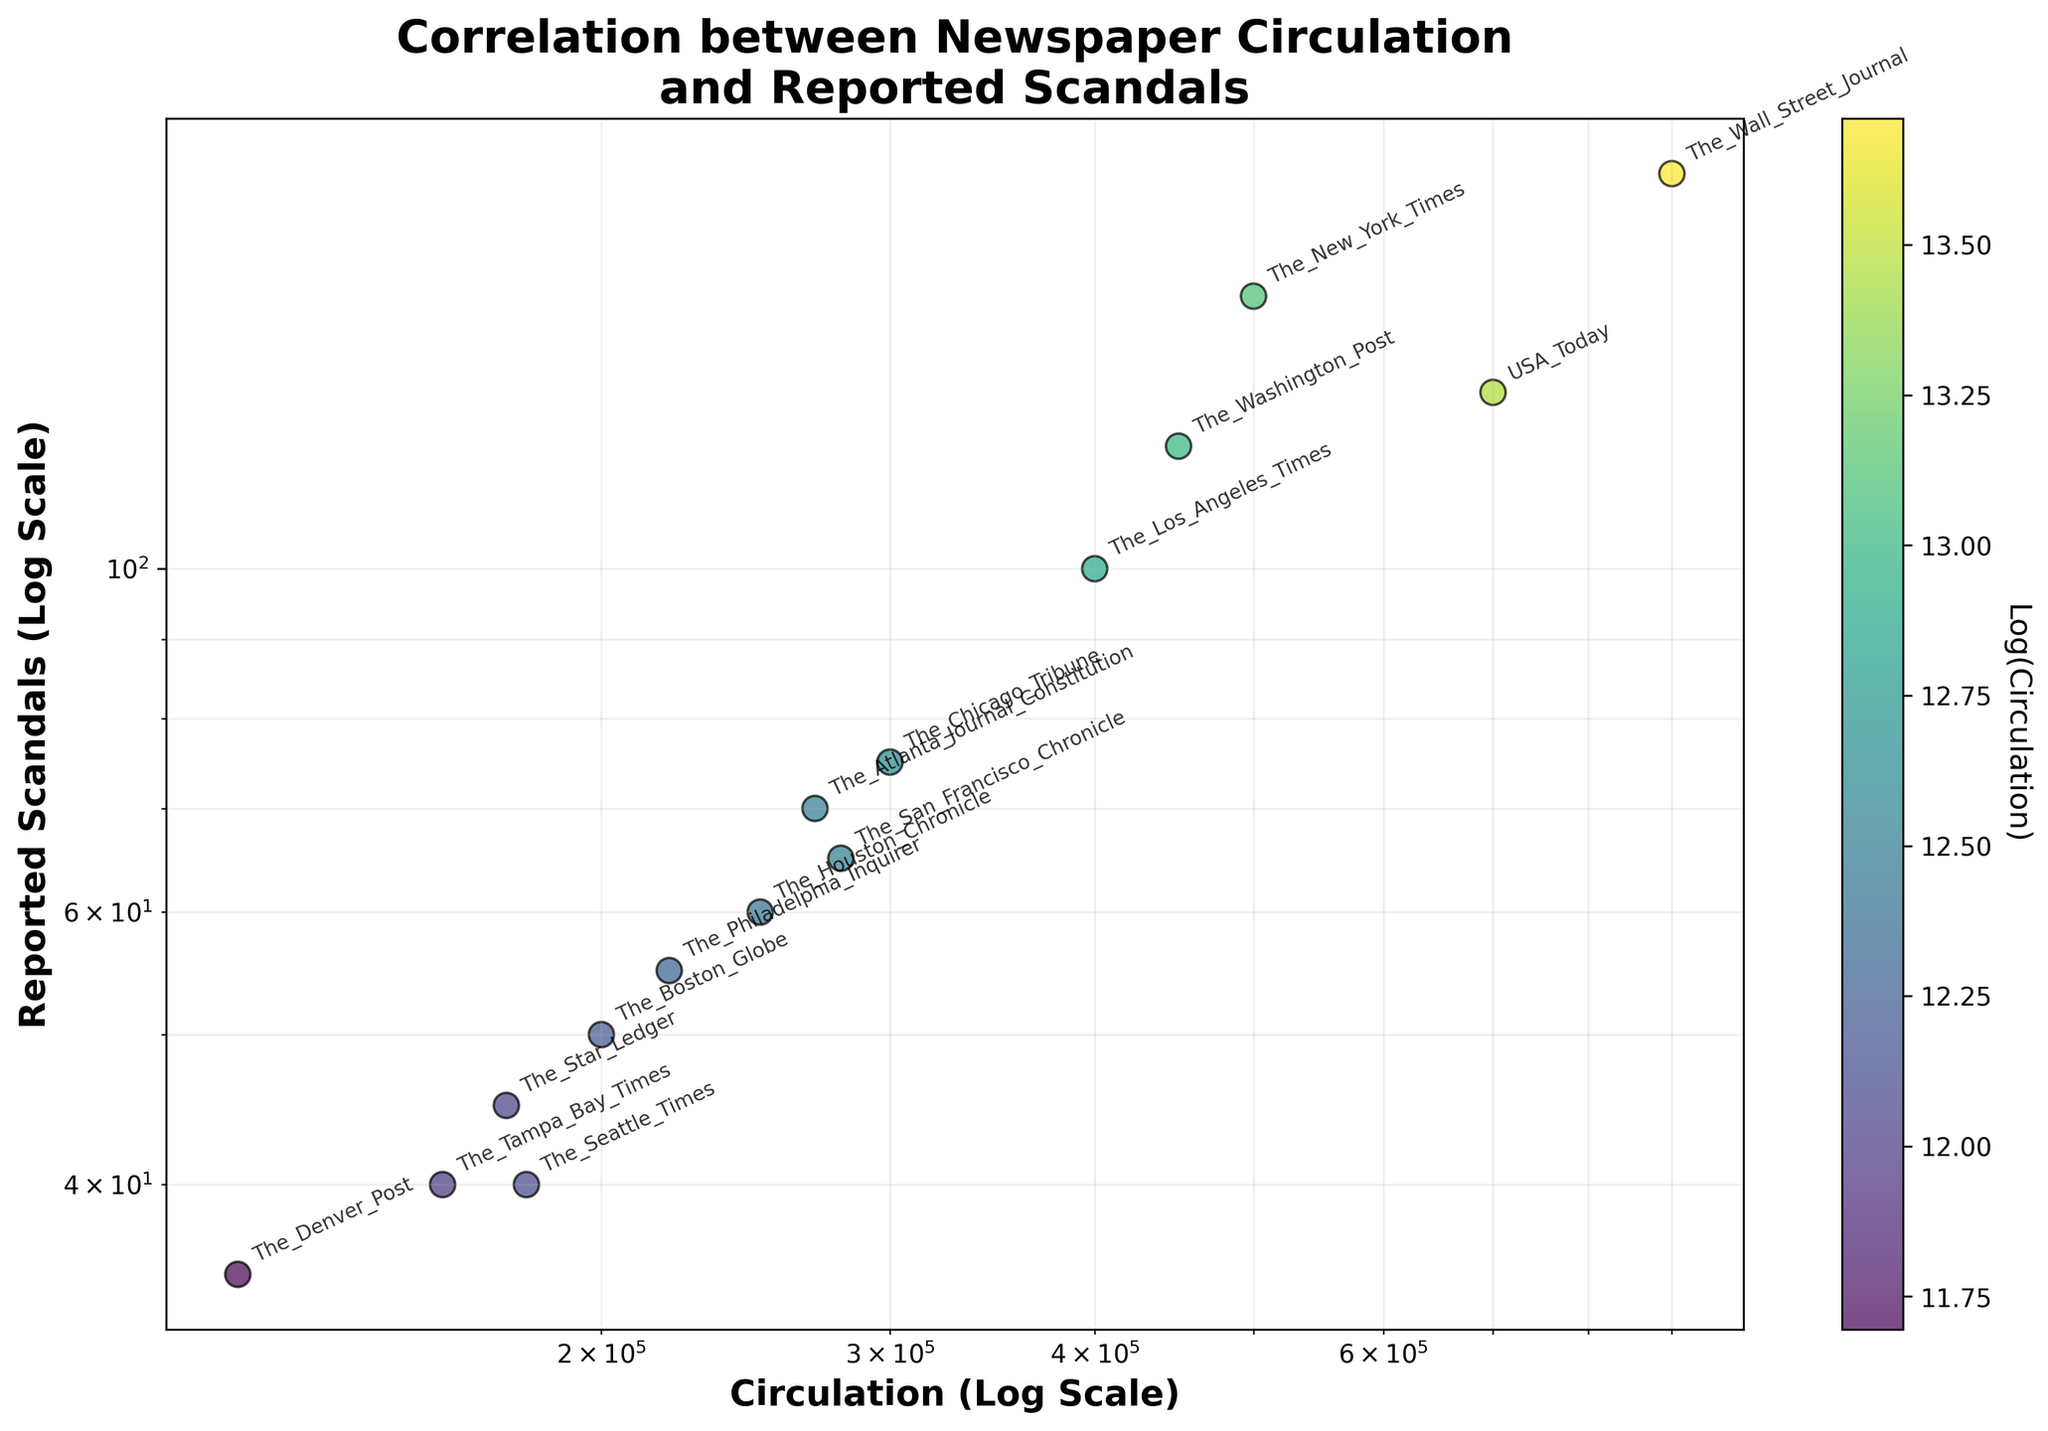How many newspapers are represented in the scatter plot? Count the number of distinct data points (newspapers) labeled in the scatter plot. There are 15 different labels for the newspapers.
Answer: 15 What is the title of the scatter plot? Look at the text at the top of the scatter plot which should denote the title. The title is "Correlation between Newspaper Circulation and Reported Scandals".
Answer: Correlation between Newspaper Circulation and Reported Scandals Which newspaper has the highest circulation? Locate the data point with the highest value on the x-axis (circulation) and check its label. The newspaper "The_Wall_Street_Journal" has the highest circulation of 900,000.
Answer: The Wall Street Journal Which newspaper reported the highest number of scandals? Locate the data point with the highest value on the y-axis (reported scandals) and check its label. "The_Wall_Street_Journal" reported the highest number of scandals, 180.
Answer: The Wall Street Journal What is the color scheme used for the data points? The color scheme is indicated by the color bar next to the scatter plot showing variations from one end to another, and it's labeled. The colors range from blue to yellow.
Answer: Blue to yellow How does the circulation of The_New_York_Times compare to that of USA_Today? Look for the data points labeled "The_New_York_Times" and "USA_Today" on the x-axis and compare their circulation values. The_New_York_Times has a circulation of 500,000 while USA_Today has 700,000.
Answer: USA_Today has a higher circulation Does The_Seattle_Times have more reported scandals than The_Denver_Post? Identify the data points for "The_Seattle_Times" and "The_Denver_Post" and compare their positions on the y-axis. The_Seattle_Times reported 40 scandals, while The_Denver_Post reported 35.
Answer: Yes Which newspaper has the lowest reported scandals? Find the data point with the lowest value on the y-axis and check its label. "The_Denver_Post" has the lowest count with 35 reported scandals.
Answer: The Denver Post Is there a visible trend between circulation and reported scandals based on the scatter plot? Observe the overall distribution pattern of the data points in the scatter plot. It appears that higher circulation numbers are generally associated with higher instances of reported scandals.
Answer: Yes, a positive correlation 